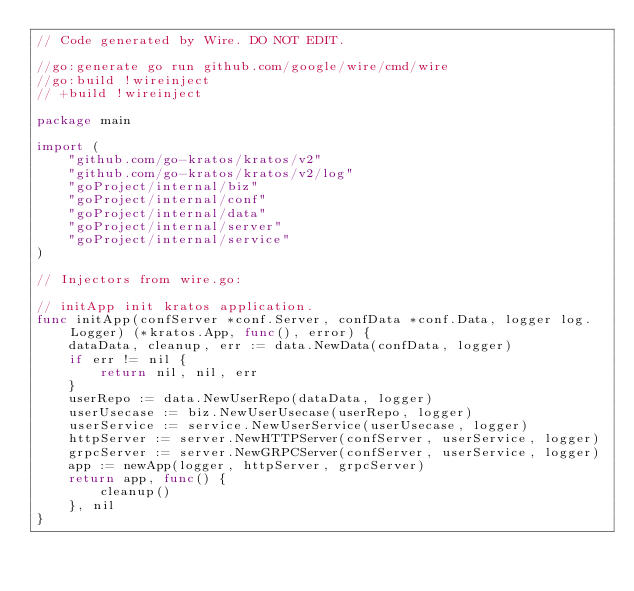<code> <loc_0><loc_0><loc_500><loc_500><_Go_>// Code generated by Wire. DO NOT EDIT.

//go:generate go run github.com/google/wire/cmd/wire
//go:build !wireinject
// +build !wireinject

package main

import (
	"github.com/go-kratos/kratos/v2"
	"github.com/go-kratos/kratos/v2/log"
	"goProject/internal/biz"
	"goProject/internal/conf"
	"goProject/internal/data"
	"goProject/internal/server"
	"goProject/internal/service"
)

// Injectors from wire.go:

// initApp init kratos application.
func initApp(confServer *conf.Server, confData *conf.Data, logger log.Logger) (*kratos.App, func(), error) {
	dataData, cleanup, err := data.NewData(confData, logger)
	if err != nil {
		return nil, nil, err
	}
	userRepo := data.NewUserRepo(dataData, logger)
	userUsecase := biz.NewUserUsecase(userRepo, logger)
	userService := service.NewUserService(userUsecase, logger)
	httpServer := server.NewHTTPServer(confServer, userService, logger)
	grpcServer := server.NewGRPCServer(confServer, userService, logger)
	app := newApp(logger, httpServer, grpcServer)
	return app, func() {
		cleanup()
	}, nil
}
</code> 